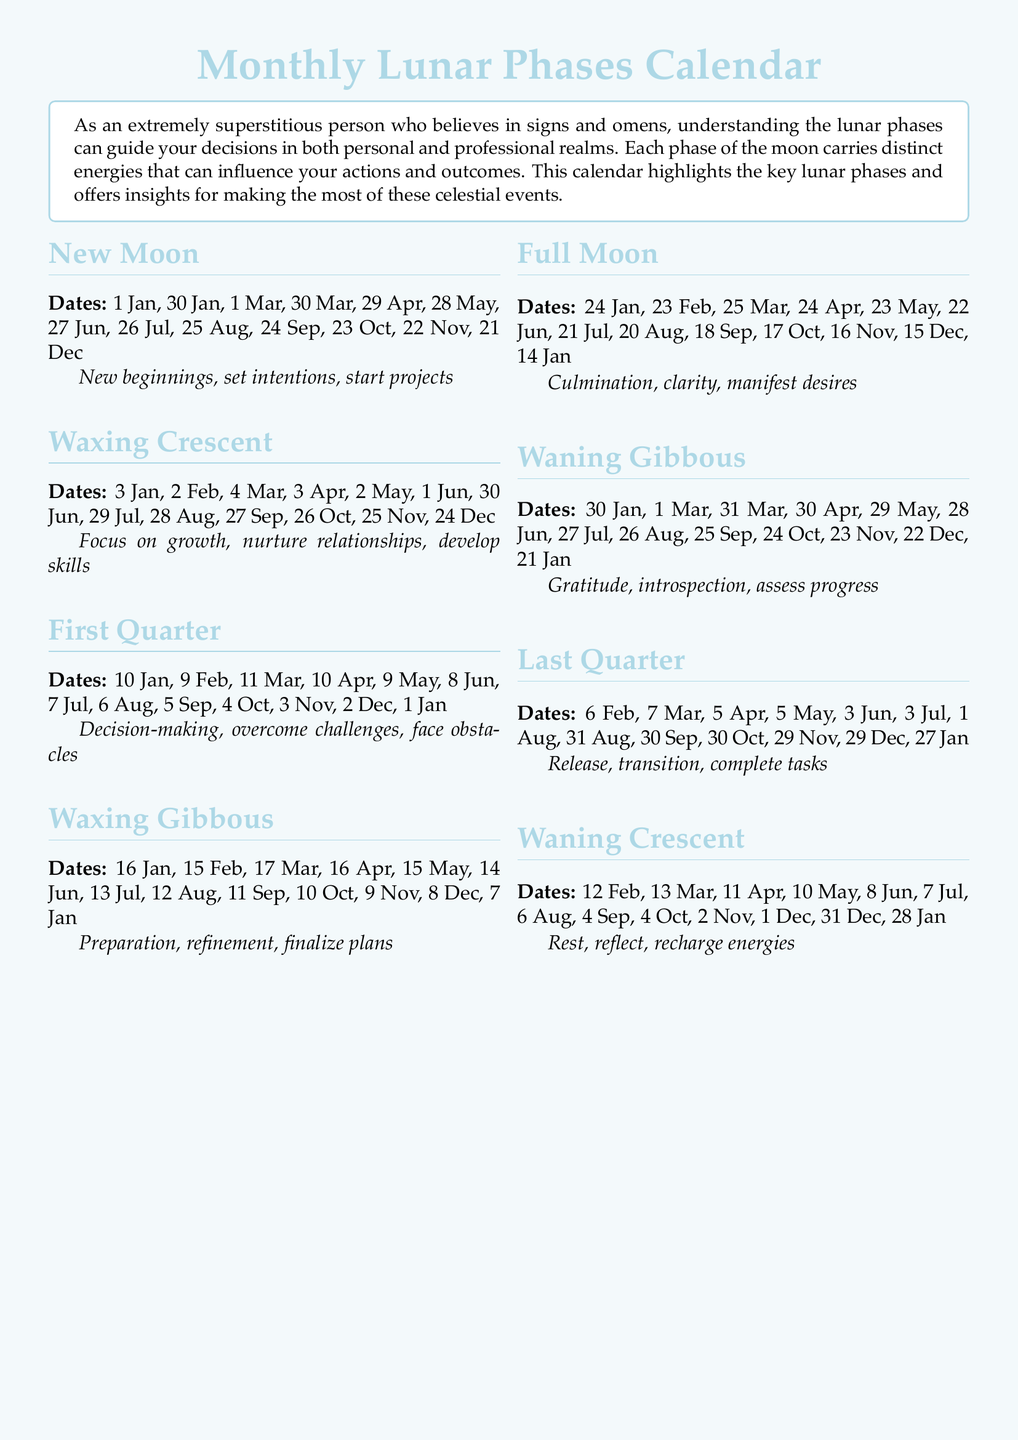What date does the Full Moon occur in January? The document lists the date of the Full Moon in January as 24 January.
Answer: 24 January What is a key intention for the New Moon phase? The New Moon phase emphasizes new beginnings, intentions, and starting projects.
Answer: New beginnings On which date does the Waxing Crescent start in March? The document specifies that the Waxing Crescent begins on 4 March.
Answer: 4 March What is the primary action associated with the Last Quarter phase? The Last Quarter phase is focused on release, transition, and completing tasks.
Answer: Release Which lunar phase is associated with preparation and finalizing plans? The Waxing Gibbous phase is characterized by preparation, refinement, and finalizing plans.
Answer: Waxing Gibbous How many lunar phases are listed in the calendar? There are a total of seven lunar phases mentioned in the calendar.
Answer: Seven When does the Waning Crescent occur in February? According to the document, the Waning Crescent occurs on 12 February.
Answer: 12 February Which lunar phase emphasizes gratitude and introspection? The Waning Gibbous phase highlights gratitude, introspection, and assessing progress.
Answer: Waning Gibbous 